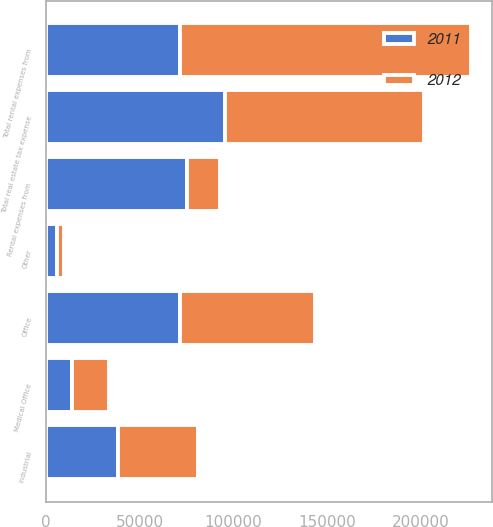Convert chart to OTSL. <chart><loc_0><loc_0><loc_500><loc_500><stacked_bar_chart><ecel><fcel>Industrial<fcel>Office<fcel>Medical Office<fcel>Other<fcel>Total rental expenses from<fcel>Rental expenses from<fcel>Total real estate tax expense<nl><fcel>2012<fcel>42830<fcel>71910<fcel>19386<fcel>3671<fcel>155390<fcel>17593<fcel>106128<nl><fcel>2011<fcel>38354<fcel>71760<fcel>13935<fcel>5668<fcel>71760<fcel>75330<fcel>95666<nl></chart> 